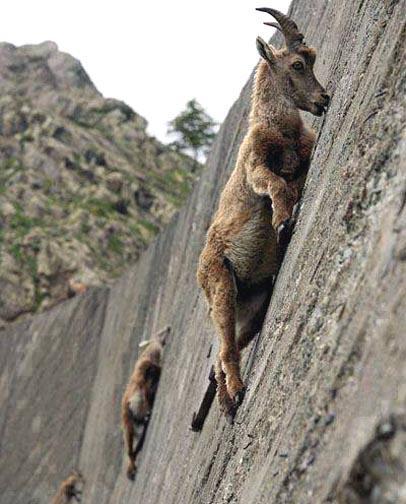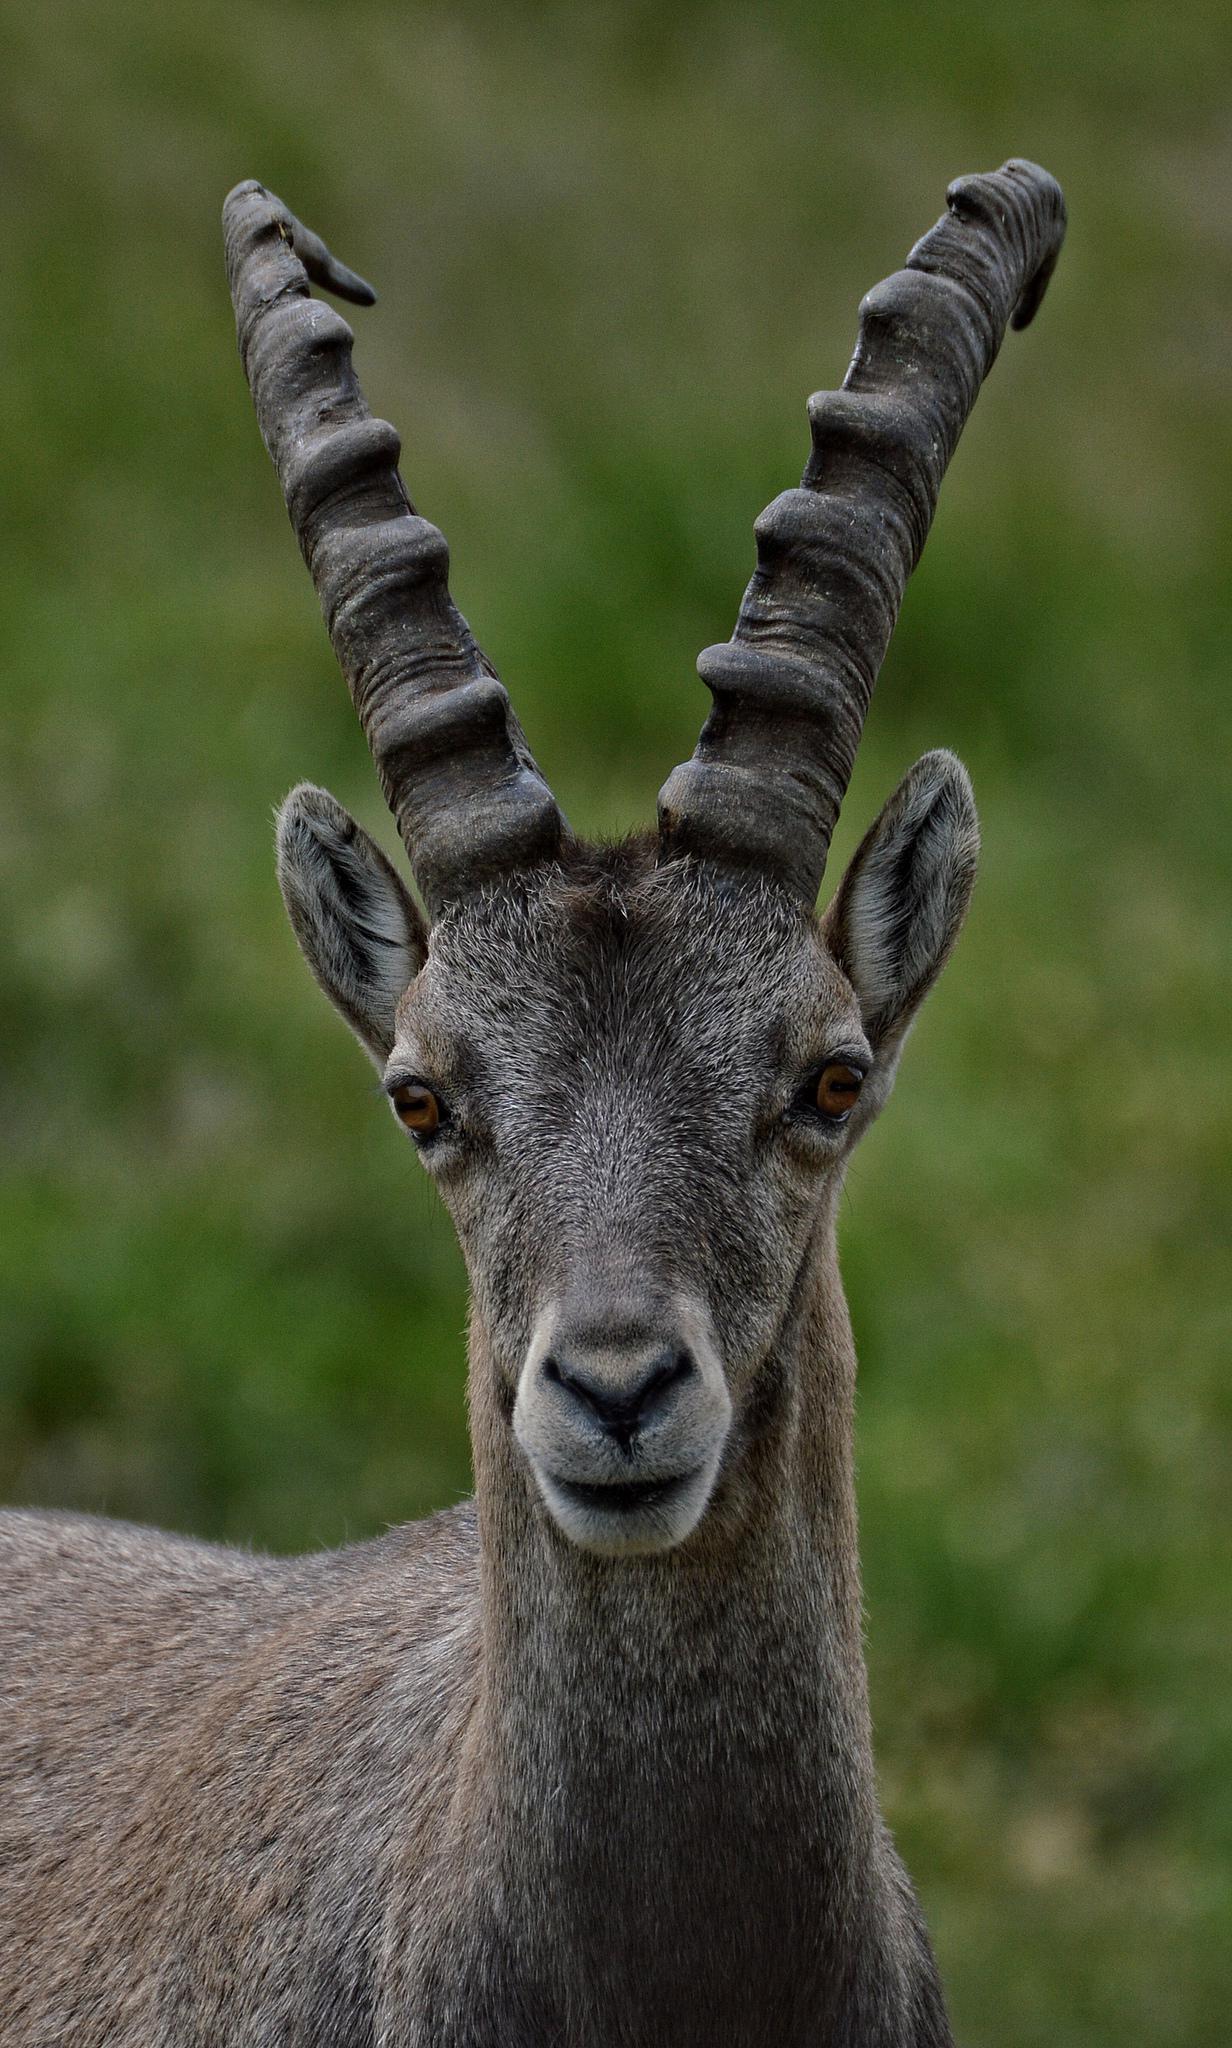The first image is the image on the left, the second image is the image on the right. For the images shown, is this caption "An image shows one camera-facing long-horned animal with an upright head, with mountain peaks in the background." true? Answer yes or no. No. 